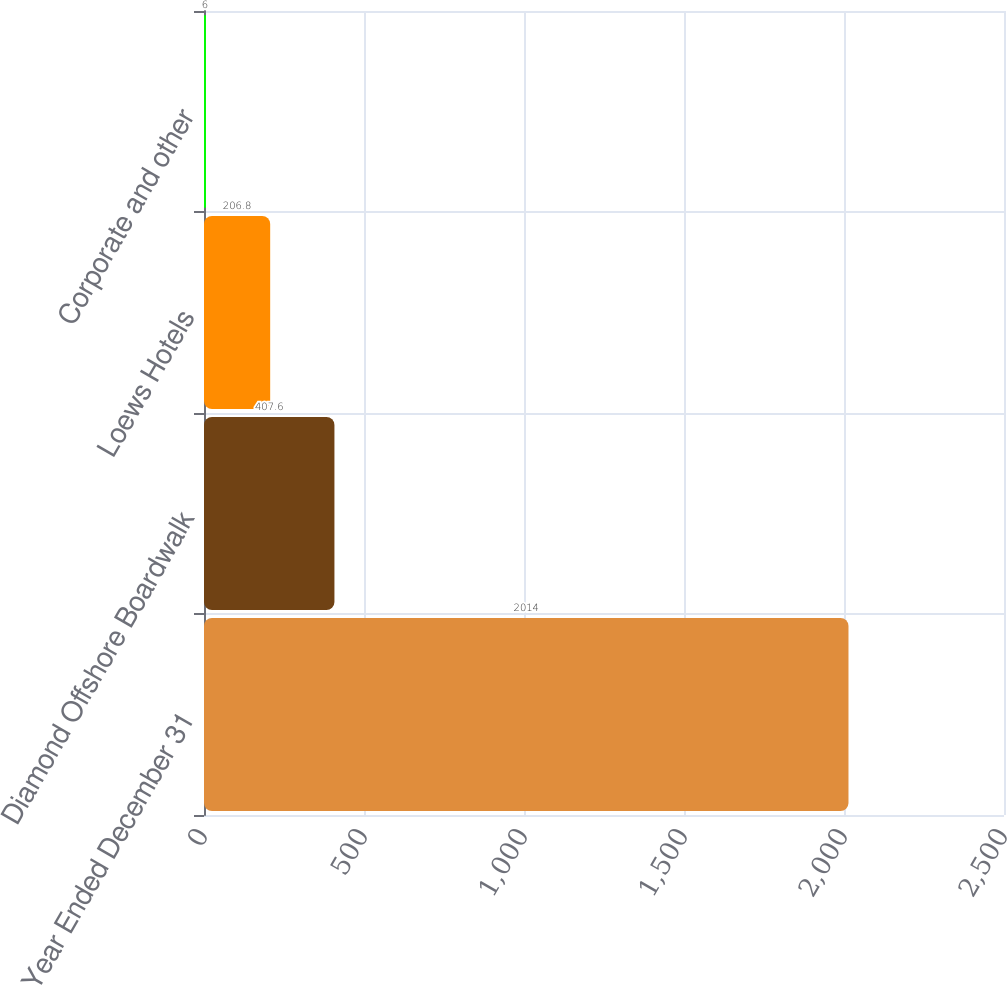<chart> <loc_0><loc_0><loc_500><loc_500><bar_chart><fcel>Year Ended December 31<fcel>Diamond Offshore Boardwalk<fcel>Loews Hotels<fcel>Corporate and other<nl><fcel>2014<fcel>407.6<fcel>206.8<fcel>6<nl></chart> 